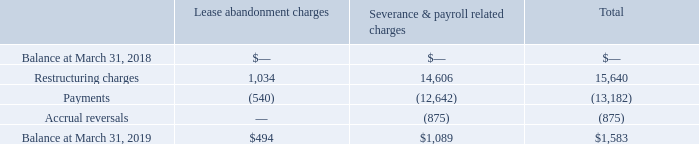12. Restructuring
In fiscal 2019, the Company initiated a restructuring plan to increase efficiency in its sales, marketing and distribution functions as well as reduce costs across all functional areas. During the year ended March 31, 2019, the Company incurred total restructuring charges of $14,765. These restructuring charges relate primarily to severance and related costs associated with headcount reductions and lease abandonment charges associated with two leases. These charges include $2,632 of stock- based compensation related to modifications of existing unvested awards granted to certain employees impacted by the restructuring plan.
The activity in the Company’s restructuring accruals for the year ended March 31, 2019 is summarized as follows:
As of March 31, 2019, the outstanding restructuring accruals primarily relate to future severance and lease payments.
(In thousands, except per share data)
How much was the Restructuring charges related to lease abandonment charges and severance and payroll related charges respectively?
Answer scale should be: thousand. 1,034, 14,606. Why did the company initiate a restructuring plan? To increase efficiency in its sales, marketing and distribution functions as well as reduce costs across all functional areas. What is the ending balance at March 31, 2019 for Lease abandonment charges and Severance & payroll related charges respectively?
Answer scale should be: thousand. $494, $1,089. What is the net total restructuring charges and payments for Severance & payroll related charges and lease abandonment charges?
Answer scale should be: thousand. 14,606-12,642+1,034-540
Answer: 2458. What fraction of the total restructuring charges included stock-based compensation? 2,632/14,765
Answer: 0.18. How much more was the balance at march 31, 2019 for Severance & payroll related charges than lease abandonment charges?
Answer scale should be: thousand. 1,089-494
Answer: 595. 